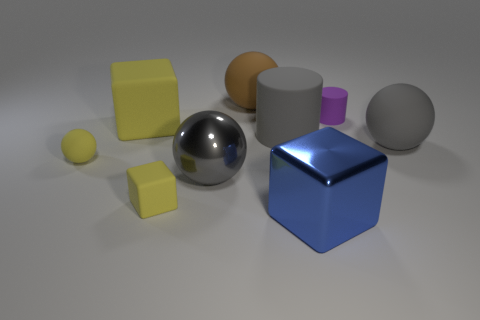There is a blue object that is the same shape as the big yellow rubber thing; what is its material? The blue object, which shares the cube shape with the larger yellow item, appears to be made of a polished metal, as indicated by its reflective surface and sharp edges. 